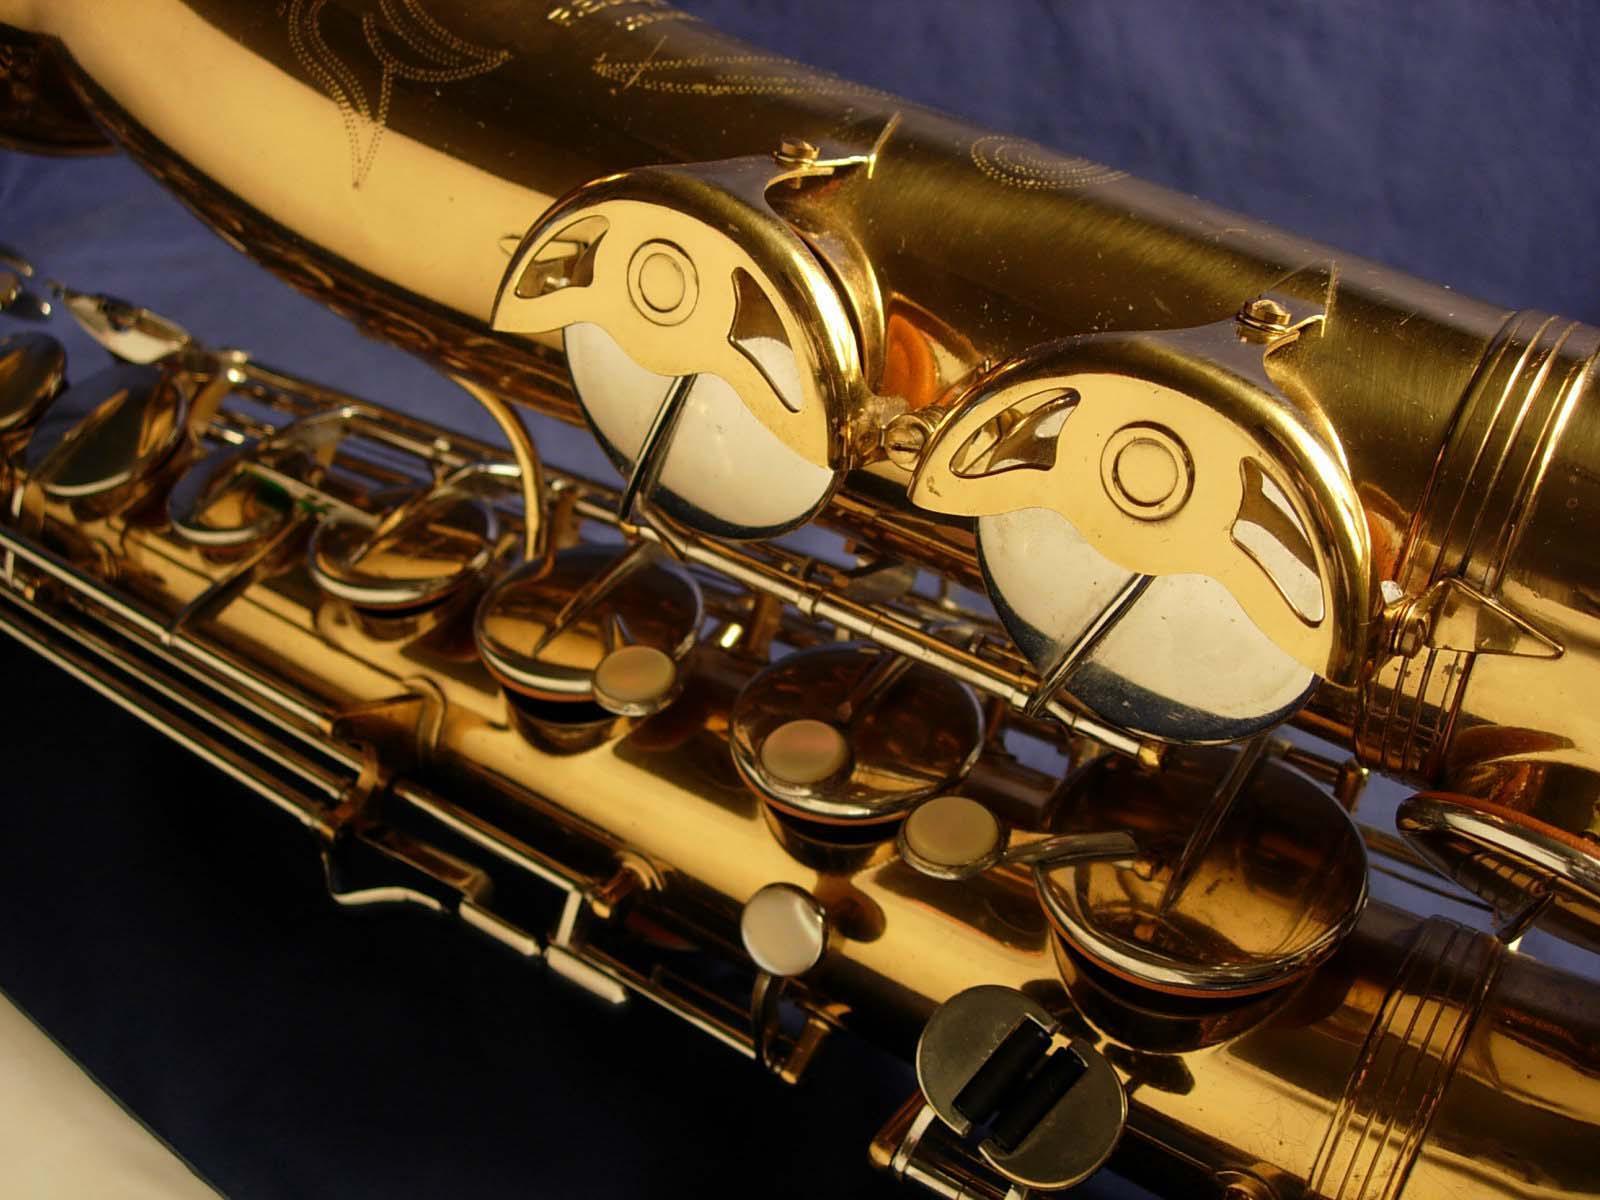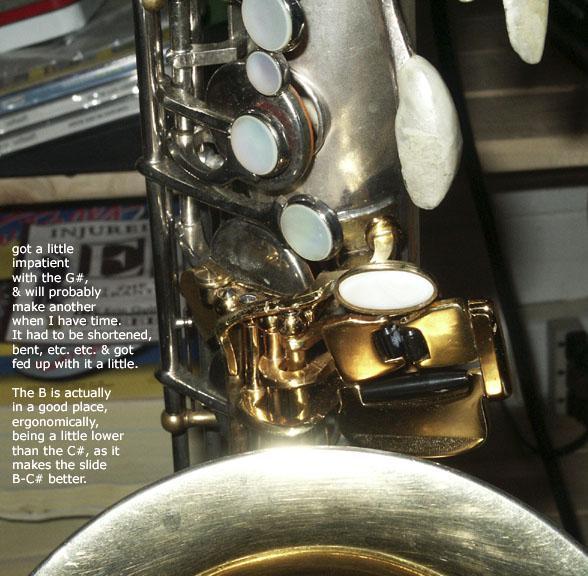The first image is the image on the left, the second image is the image on the right. Evaluate the accuracy of this statement regarding the images: "One image shows the etched bell of a gold saxophone, which is displayed on burgundy fabric.". Is it true? Answer yes or no. No. The first image is the image on the left, the second image is the image on the right. Assess this claim about the two images: "The saxophone in the image on the right is sitting in a case with a red lining.". Correct or not? Answer yes or no. No. 